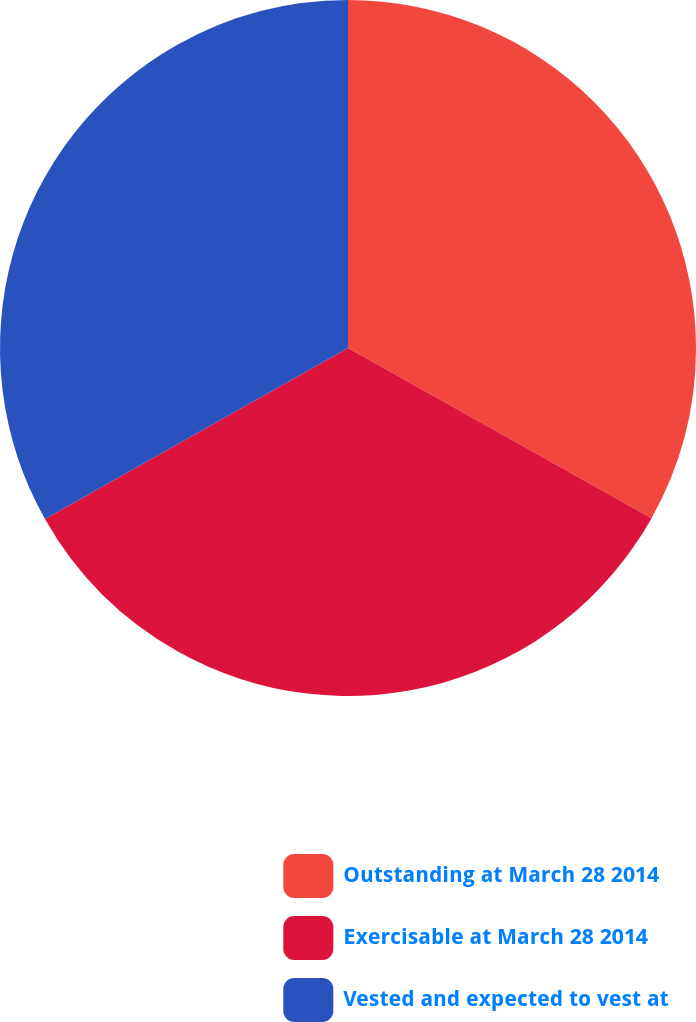Convert chart. <chart><loc_0><loc_0><loc_500><loc_500><pie_chart><fcel>Outstanding at March 28 2014<fcel>Exercisable at March 28 2014<fcel>Vested and expected to vest at<nl><fcel>33.13%<fcel>33.69%<fcel>33.18%<nl></chart> 